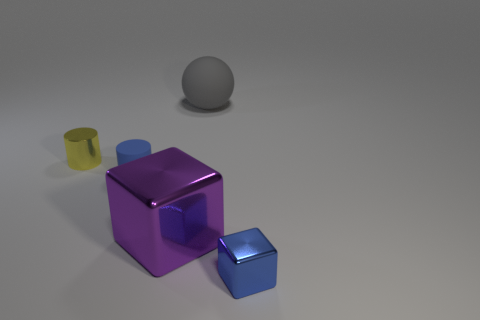The matte object that is the same color as the tiny shiny block is what shape?
Provide a short and direct response. Cylinder. What is the size of the matte thing that is the same color as the small metal cube?
Your response must be concise. Small. There is a block left of the tiny metallic thing right of the cylinder that is in front of the tiny yellow thing; what is its color?
Make the answer very short. Purple. What number of other objects are there of the same shape as the purple shiny thing?
Offer a terse response. 1. There is a tiny metal thing left of the rubber sphere; what is its shape?
Provide a short and direct response. Cylinder. Are there any small cylinders left of the blue cylinder to the left of the big sphere?
Give a very brief answer. Yes. What is the color of the metal object that is both behind the small blue shiny object and in front of the blue cylinder?
Offer a very short reply. Purple. There is a block that is behind the tiny metal object that is in front of the metal cylinder; is there a metal object behind it?
Your response must be concise. Yes. There is another metallic object that is the same shape as the tiny blue shiny thing; what is its size?
Provide a short and direct response. Large. Is there a block?
Your answer should be very brief. Yes. 